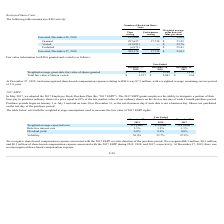According to Ichor Holdings's financial document, When did the company adopt the 2017 Employee Stock Purchase Plan (the “2017 ESPP”)? According to the financial document, May 2017. The relevant text states: "In May 2017, we adopted the 2017 Employee Stock Purchase Plan (the “2017 ESPP”). The 2017 ESPP grants employees..." Also, When are shares purchased? Shares are purchased on the last day of the purchase period.. The document states: "t business day if such date is not a business day. Shares are purchased on the last day of the purchase period...." Also, When do the purchase periods begin? According to the financial document, January 1 or July 1. The relevant text states: "month purchase period. Purchase periods begin on January 1 or July 1 and end on June 30 or December 31, or the next business day if such date is not a business day. Sha..." Also, How many weighted average assumptions are used to measure the fair value of 2017 ESPP rights? Counting the relevant items in the document: Weighted average expected term, Risk-free interest rate, Dividend yield, Volatility, I find 4 instances. The key data points involved are: Dividend yield, Risk-free interest rate, Volatility. Also, can you calculate: What was the average risk-free interest rate for the 3 year period from 2017 to 2019? To answer this question, I need to perform calculations using the financial data. The calculation is: (2.3%+1.9%+1.1%)/(2019-2017+1), which equals 1.77 (percentage). This is based on the information: "Risk-free interest rate 2.3% 1.9% 1.1% Risk-free interest rate 2.3% 1.9% 1.1% Unvested, December 27, 2019 389,170 17,730 $ 23.03 Unvested, December 27, 2019 389,170 17,730 $ 23.03 2017 Risk-free inter..." The key data points involved are: 1.1, 1.9, 2.3. Also, How many years during the 3 year period had volatility of greater than 50.0%? Counting the relevant items in the document: 56.0%, 52.7%, I find 2 instances. The key data points involved are: 52.7%, 56.0%. 